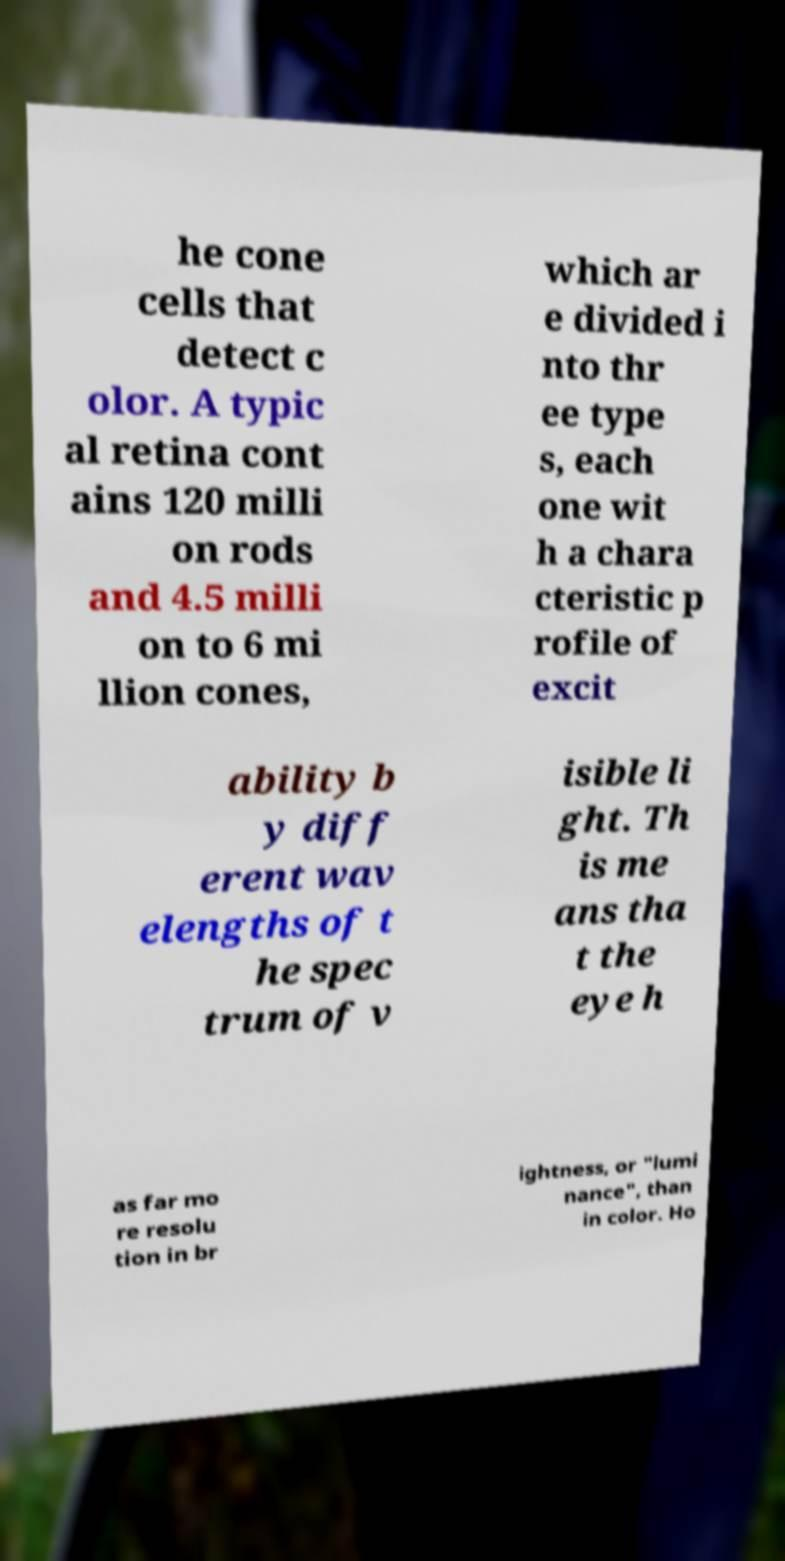I need the written content from this picture converted into text. Can you do that? he cone cells that detect c olor. A typic al retina cont ains 120 milli on rods and 4.5 milli on to 6 mi llion cones, which ar e divided i nto thr ee type s, each one wit h a chara cteristic p rofile of excit ability b y diff erent wav elengths of t he spec trum of v isible li ght. Th is me ans tha t the eye h as far mo re resolu tion in br ightness, or "lumi nance", than in color. Ho 